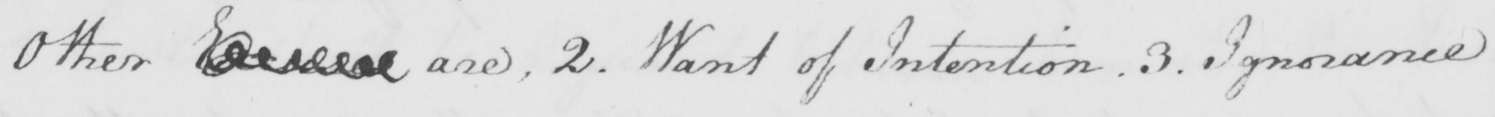Transcribe the text shown in this historical manuscript line. Other Excuses are , 2 . Want of Intention . 3 . Ignorance 